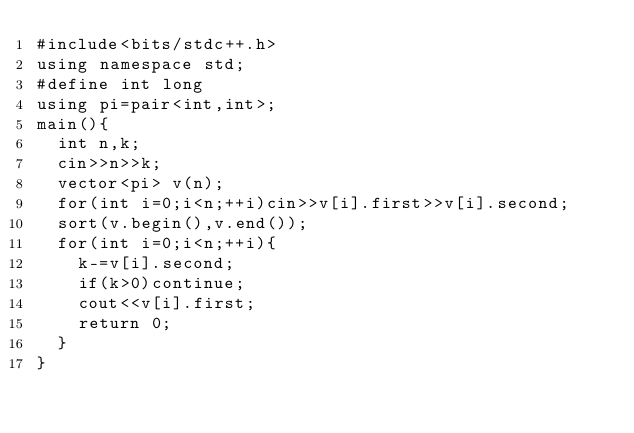Convert code to text. <code><loc_0><loc_0><loc_500><loc_500><_C++_>#include<bits/stdc++.h>
using namespace std;
#define int long
using pi=pair<int,int>;
main(){
  int n,k;
  cin>>n>>k;
  vector<pi> v(n);
  for(int i=0;i<n;++i)cin>>v[i].first>>v[i].second;
  sort(v.begin(),v.end());
  for(int i=0;i<n;++i){
    k-=v[i].second;
    if(k>0)continue;
    cout<<v[i].first;
    return 0;
  }
}</code> 